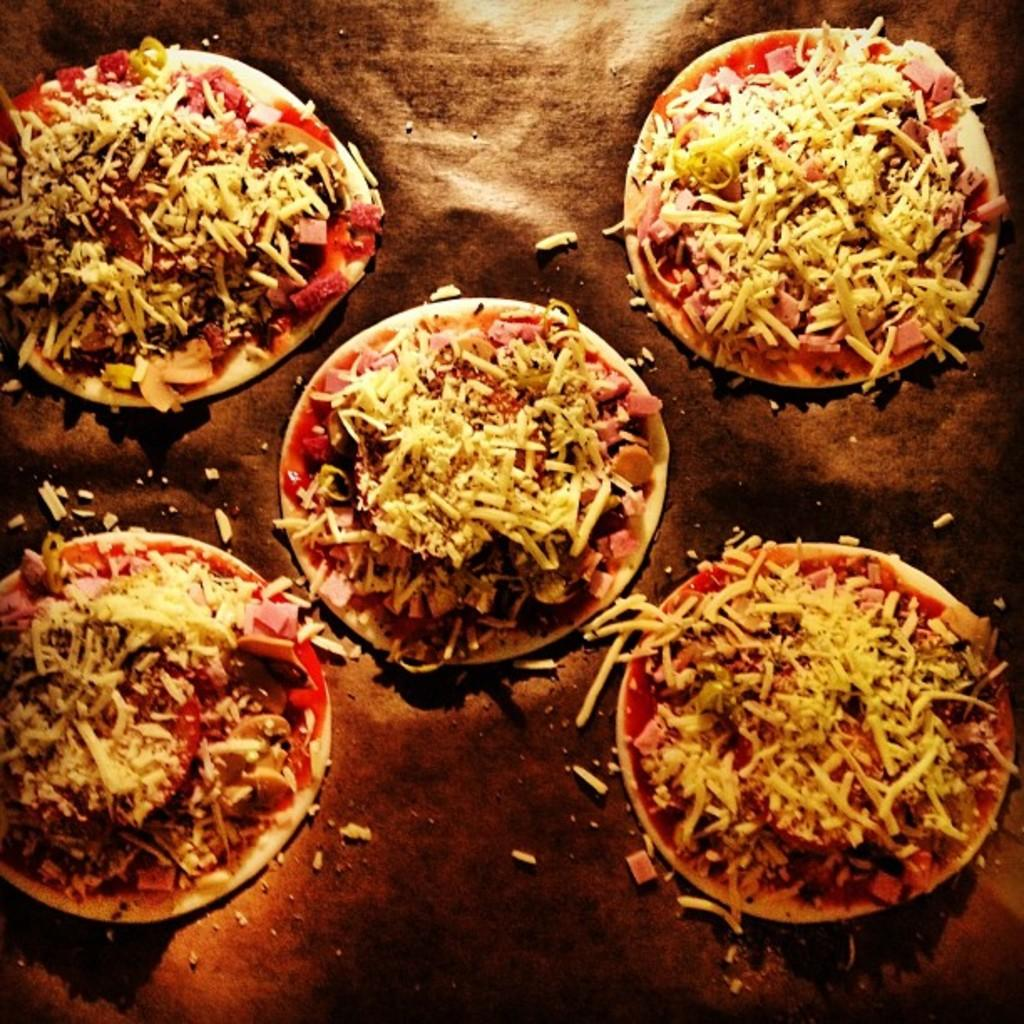What is present on the plates in the image? There are plates with food in the image. What type of surface might the plates be placed on in the image? There is an object in the image that resembles a table. Can you see any letters being written on the plates in the image? There are no letters being written on the plates in the image. Is there a hose visible in the image? There is no hose present in the image. 